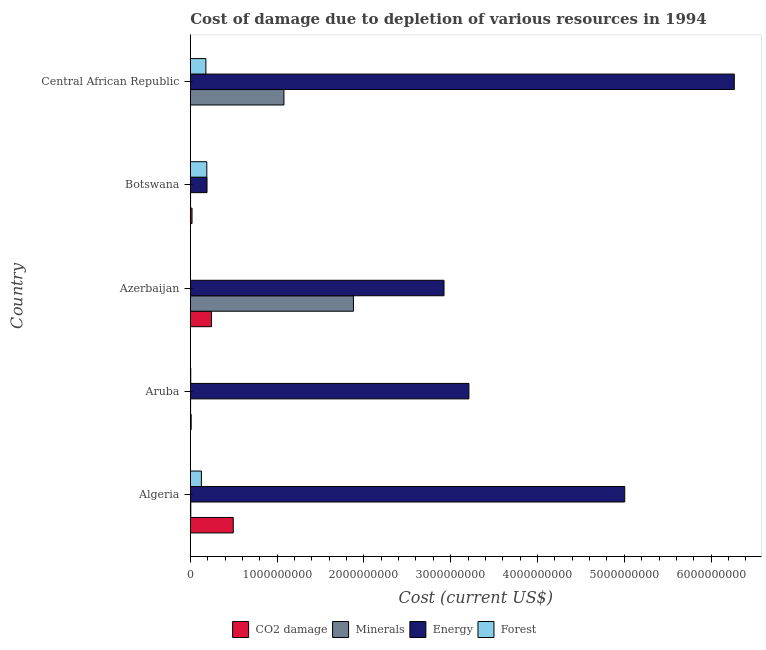How many groups of bars are there?
Offer a very short reply. 5. Are the number of bars on each tick of the Y-axis equal?
Give a very brief answer. Yes. What is the label of the 5th group of bars from the top?
Provide a succinct answer. Algeria. In how many cases, is the number of bars for a given country not equal to the number of legend labels?
Ensure brevity in your answer.  0. What is the cost of damage due to depletion of forests in Botswana?
Your answer should be compact. 1.90e+08. Across all countries, what is the maximum cost of damage due to depletion of coal?
Offer a very short reply. 4.95e+08. Across all countries, what is the minimum cost of damage due to depletion of forests?
Offer a very short reply. 4.39e+05. In which country was the cost of damage due to depletion of forests maximum?
Ensure brevity in your answer.  Botswana. In which country was the cost of damage due to depletion of forests minimum?
Make the answer very short. Azerbaijan. What is the total cost of damage due to depletion of coal in the graph?
Keep it short and to the point. 7.70e+08. What is the difference between the cost of damage due to depletion of forests in Algeria and that in Botswana?
Ensure brevity in your answer.  -6.25e+07. What is the difference between the cost of damage due to depletion of minerals in Botswana and the cost of damage due to depletion of forests in Central African Republic?
Keep it short and to the point. -1.77e+08. What is the average cost of damage due to depletion of energy per country?
Give a very brief answer. 3.52e+09. What is the difference between the cost of damage due to depletion of minerals and cost of damage due to depletion of energy in Algeria?
Offer a terse response. -5.00e+09. In how many countries, is the cost of damage due to depletion of energy greater than 5600000000 US$?
Provide a short and direct response. 1. What is the ratio of the cost of damage due to depletion of forests in Azerbaijan to that in Botswana?
Provide a succinct answer. 0. What is the difference between the highest and the second highest cost of damage due to depletion of coal?
Make the answer very short. 2.51e+08. What is the difference between the highest and the lowest cost of damage due to depletion of energy?
Give a very brief answer. 6.07e+09. Is the sum of the cost of damage due to depletion of coal in Azerbaijan and Central African Republic greater than the maximum cost of damage due to depletion of minerals across all countries?
Your answer should be very brief. No. Is it the case that in every country, the sum of the cost of damage due to depletion of energy and cost of damage due to depletion of coal is greater than the sum of cost of damage due to depletion of forests and cost of damage due to depletion of minerals?
Ensure brevity in your answer.  Yes. What does the 4th bar from the top in Aruba represents?
Provide a short and direct response. CO2 damage. What does the 1st bar from the bottom in Aruba represents?
Your answer should be very brief. CO2 damage. How many countries are there in the graph?
Give a very brief answer. 5. Are the values on the major ticks of X-axis written in scientific E-notation?
Offer a terse response. No. Does the graph contain any zero values?
Offer a very short reply. No. Does the graph contain grids?
Your answer should be compact. No. Where does the legend appear in the graph?
Your answer should be compact. Bottom center. How many legend labels are there?
Your answer should be very brief. 4. How are the legend labels stacked?
Make the answer very short. Horizontal. What is the title of the graph?
Keep it short and to the point. Cost of damage due to depletion of various resources in 1994 . Does "Source data assessment" appear as one of the legend labels in the graph?
Make the answer very short. No. What is the label or title of the X-axis?
Your answer should be compact. Cost (current US$). What is the label or title of the Y-axis?
Ensure brevity in your answer.  Country. What is the Cost (current US$) of CO2 damage in Algeria?
Provide a succinct answer. 4.95e+08. What is the Cost (current US$) of Minerals in Algeria?
Your response must be concise. 5.54e+06. What is the Cost (current US$) in Energy in Algeria?
Ensure brevity in your answer.  5.01e+09. What is the Cost (current US$) of Forest in Algeria?
Your answer should be very brief. 1.28e+08. What is the Cost (current US$) in CO2 damage in Aruba?
Provide a short and direct response. 1.01e+07. What is the Cost (current US$) in Minerals in Aruba?
Ensure brevity in your answer.  3.46e+06. What is the Cost (current US$) of Energy in Aruba?
Offer a very short reply. 3.21e+09. What is the Cost (current US$) in Forest in Aruba?
Keep it short and to the point. 5.19e+06. What is the Cost (current US$) in CO2 damage in Azerbaijan?
Give a very brief answer. 2.44e+08. What is the Cost (current US$) in Minerals in Azerbaijan?
Give a very brief answer. 1.88e+09. What is the Cost (current US$) of Energy in Azerbaijan?
Ensure brevity in your answer.  2.92e+09. What is the Cost (current US$) of Forest in Azerbaijan?
Offer a terse response. 4.39e+05. What is the Cost (current US$) of CO2 damage in Botswana?
Provide a short and direct response. 2.00e+07. What is the Cost (current US$) in Minerals in Botswana?
Give a very brief answer. 3.12e+06. What is the Cost (current US$) of Energy in Botswana?
Provide a succinct answer. 1.93e+08. What is the Cost (current US$) of Forest in Botswana?
Your response must be concise. 1.90e+08. What is the Cost (current US$) of CO2 damage in Central African Republic?
Make the answer very short. 1.34e+06. What is the Cost (current US$) of Minerals in Central African Republic?
Your answer should be compact. 1.08e+09. What is the Cost (current US$) in Energy in Central African Republic?
Provide a succinct answer. 6.27e+09. What is the Cost (current US$) in Forest in Central African Republic?
Provide a short and direct response. 1.80e+08. Across all countries, what is the maximum Cost (current US$) of CO2 damage?
Keep it short and to the point. 4.95e+08. Across all countries, what is the maximum Cost (current US$) in Minerals?
Your response must be concise. 1.88e+09. Across all countries, what is the maximum Cost (current US$) of Energy?
Your answer should be compact. 6.27e+09. Across all countries, what is the maximum Cost (current US$) of Forest?
Your answer should be compact. 1.90e+08. Across all countries, what is the minimum Cost (current US$) of CO2 damage?
Provide a short and direct response. 1.34e+06. Across all countries, what is the minimum Cost (current US$) of Minerals?
Your answer should be compact. 3.12e+06. Across all countries, what is the minimum Cost (current US$) of Energy?
Provide a succinct answer. 1.93e+08. Across all countries, what is the minimum Cost (current US$) of Forest?
Keep it short and to the point. 4.39e+05. What is the total Cost (current US$) in CO2 damage in the graph?
Your response must be concise. 7.70e+08. What is the total Cost (current US$) in Minerals in the graph?
Provide a succinct answer. 2.97e+09. What is the total Cost (current US$) in Energy in the graph?
Your response must be concise. 1.76e+1. What is the total Cost (current US$) in Forest in the graph?
Keep it short and to the point. 5.03e+08. What is the difference between the Cost (current US$) in CO2 damage in Algeria and that in Aruba?
Your answer should be compact. 4.85e+08. What is the difference between the Cost (current US$) of Minerals in Algeria and that in Aruba?
Your answer should be very brief. 2.08e+06. What is the difference between the Cost (current US$) in Energy in Algeria and that in Aruba?
Offer a very short reply. 1.80e+09. What is the difference between the Cost (current US$) of Forest in Algeria and that in Aruba?
Make the answer very short. 1.23e+08. What is the difference between the Cost (current US$) of CO2 damage in Algeria and that in Azerbaijan?
Provide a succinct answer. 2.51e+08. What is the difference between the Cost (current US$) of Minerals in Algeria and that in Azerbaijan?
Your answer should be compact. -1.87e+09. What is the difference between the Cost (current US$) in Energy in Algeria and that in Azerbaijan?
Offer a terse response. 2.08e+09. What is the difference between the Cost (current US$) in Forest in Algeria and that in Azerbaijan?
Keep it short and to the point. 1.27e+08. What is the difference between the Cost (current US$) in CO2 damage in Algeria and that in Botswana?
Keep it short and to the point. 4.75e+08. What is the difference between the Cost (current US$) of Minerals in Algeria and that in Botswana?
Ensure brevity in your answer.  2.42e+06. What is the difference between the Cost (current US$) of Energy in Algeria and that in Botswana?
Your answer should be very brief. 4.81e+09. What is the difference between the Cost (current US$) in Forest in Algeria and that in Botswana?
Keep it short and to the point. -6.25e+07. What is the difference between the Cost (current US$) of CO2 damage in Algeria and that in Central African Republic?
Your response must be concise. 4.94e+08. What is the difference between the Cost (current US$) of Minerals in Algeria and that in Central African Republic?
Your response must be concise. -1.07e+09. What is the difference between the Cost (current US$) of Energy in Algeria and that in Central African Republic?
Offer a very short reply. -1.26e+09. What is the difference between the Cost (current US$) in Forest in Algeria and that in Central African Republic?
Offer a very short reply. -5.19e+07. What is the difference between the Cost (current US$) of CO2 damage in Aruba and that in Azerbaijan?
Your answer should be compact. -2.34e+08. What is the difference between the Cost (current US$) of Minerals in Aruba and that in Azerbaijan?
Give a very brief answer. -1.88e+09. What is the difference between the Cost (current US$) in Energy in Aruba and that in Azerbaijan?
Offer a very short reply. 2.87e+08. What is the difference between the Cost (current US$) in Forest in Aruba and that in Azerbaijan?
Your answer should be very brief. 4.75e+06. What is the difference between the Cost (current US$) in CO2 damage in Aruba and that in Botswana?
Offer a terse response. -9.90e+06. What is the difference between the Cost (current US$) in Minerals in Aruba and that in Botswana?
Give a very brief answer. 3.38e+05. What is the difference between the Cost (current US$) of Energy in Aruba and that in Botswana?
Your answer should be compact. 3.02e+09. What is the difference between the Cost (current US$) of Forest in Aruba and that in Botswana?
Provide a short and direct response. -1.85e+08. What is the difference between the Cost (current US$) of CO2 damage in Aruba and that in Central African Republic?
Keep it short and to the point. 8.75e+06. What is the difference between the Cost (current US$) in Minerals in Aruba and that in Central African Republic?
Offer a very short reply. -1.08e+09. What is the difference between the Cost (current US$) in Energy in Aruba and that in Central African Republic?
Give a very brief answer. -3.06e+09. What is the difference between the Cost (current US$) in Forest in Aruba and that in Central African Republic?
Offer a terse response. -1.74e+08. What is the difference between the Cost (current US$) in CO2 damage in Azerbaijan and that in Botswana?
Your answer should be very brief. 2.24e+08. What is the difference between the Cost (current US$) of Minerals in Azerbaijan and that in Botswana?
Your answer should be compact. 1.88e+09. What is the difference between the Cost (current US$) of Energy in Azerbaijan and that in Botswana?
Ensure brevity in your answer.  2.73e+09. What is the difference between the Cost (current US$) of Forest in Azerbaijan and that in Botswana?
Your answer should be very brief. -1.90e+08. What is the difference between the Cost (current US$) in CO2 damage in Azerbaijan and that in Central African Republic?
Your response must be concise. 2.43e+08. What is the difference between the Cost (current US$) of Minerals in Azerbaijan and that in Central African Republic?
Ensure brevity in your answer.  8.01e+08. What is the difference between the Cost (current US$) of Energy in Azerbaijan and that in Central African Republic?
Offer a terse response. -3.34e+09. What is the difference between the Cost (current US$) of Forest in Azerbaijan and that in Central African Republic?
Your answer should be compact. -1.79e+08. What is the difference between the Cost (current US$) of CO2 damage in Botswana and that in Central African Republic?
Keep it short and to the point. 1.87e+07. What is the difference between the Cost (current US$) in Minerals in Botswana and that in Central African Republic?
Your answer should be compact. -1.08e+09. What is the difference between the Cost (current US$) in Energy in Botswana and that in Central African Republic?
Your answer should be compact. -6.07e+09. What is the difference between the Cost (current US$) of Forest in Botswana and that in Central African Republic?
Give a very brief answer. 1.06e+07. What is the difference between the Cost (current US$) of CO2 damage in Algeria and the Cost (current US$) of Minerals in Aruba?
Offer a very short reply. 4.91e+08. What is the difference between the Cost (current US$) in CO2 damage in Algeria and the Cost (current US$) in Energy in Aruba?
Provide a succinct answer. -2.71e+09. What is the difference between the Cost (current US$) of CO2 damage in Algeria and the Cost (current US$) of Forest in Aruba?
Provide a succinct answer. 4.90e+08. What is the difference between the Cost (current US$) of Minerals in Algeria and the Cost (current US$) of Energy in Aruba?
Your answer should be very brief. -3.20e+09. What is the difference between the Cost (current US$) of Minerals in Algeria and the Cost (current US$) of Forest in Aruba?
Your answer should be compact. 3.60e+05. What is the difference between the Cost (current US$) of Energy in Algeria and the Cost (current US$) of Forest in Aruba?
Make the answer very short. 5.00e+09. What is the difference between the Cost (current US$) of CO2 damage in Algeria and the Cost (current US$) of Minerals in Azerbaijan?
Make the answer very short. -1.38e+09. What is the difference between the Cost (current US$) in CO2 damage in Algeria and the Cost (current US$) in Energy in Azerbaijan?
Offer a very short reply. -2.43e+09. What is the difference between the Cost (current US$) of CO2 damage in Algeria and the Cost (current US$) of Forest in Azerbaijan?
Provide a succinct answer. 4.94e+08. What is the difference between the Cost (current US$) in Minerals in Algeria and the Cost (current US$) in Energy in Azerbaijan?
Offer a very short reply. -2.92e+09. What is the difference between the Cost (current US$) in Minerals in Algeria and the Cost (current US$) in Forest in Azerbaijan?
Give a very brief answer. 5.11e+06. What is the difference between the Cost (current US$) in Energy in Algeria and the Cost (current US$) in Forest in Azerbaijan?
Provide a succinct answer. 5.00e+09. What is the difference between the Cost (current US$) of CO2 damage in Algeria and the Cost (current US$) of Minerals in Botswana?
Provide a succinct answer. 4.92e+08. What is the difference between the Cost (current US$) in CO2 damage in Algeria and the Cost (current US$) in Energy in Botswana?
Make the answer very short. 3.02e+08. What is the difference between the Cost (current US$) of CO2 damage in Algeria and the Cost (current US$) of Forest in Botswana?
Ensure brevity in your answer.  3.05e+08. What is the difference between the Cost (current US$) of Minerals in Algeria and the Cost (current US$) of Energy in Botswana?
Your response must be concise. -1.87e+08. What is the difference between the Cost (current US$) in Minerals in Algeria and the Cost (current US$) in Forest in Botswana?
Keep it short and to the point. -1.85e+08. What is the difference between the Cost (current US$) of Energy in Algeria and the Cost (current US$) of Forest in Botswana?
Your answer should be compact. 4.81e+09. What is the difference between the Cost (current US$) of CO2 damage in Algeria and the Cost (current US$) of Minerals in Central African Republic?
Provide a short and direct response. -5.84e+08. What is the difference between the Cost (current US$) of CO2 damage in Algeria and the Cost (current US$) of Energy in Central African Republic?
Offer a very short reply. -5.77e+09. What is the difference between the Cost (current US$) of CO2 damage in Algeria and the Cost (current US$) of Forest in Central African Republic?
Your response must be concise. 3.15e+08. What is the difference between the Cost (current US$) in Minerals in Algeria and the Cost (current US$) in Energy in Central African Republic?
Ensure brevity in your answer.  -6.26e+09. What is the difference between the Cost (current US$) of Minerals in Algeria and the Cost (current US$) of Forest in Central African Republic?
Your answer should be compact. -1.74e+08. What is the difference between the Cost (current US$) in Energy in Algeria and the Cost (current US$) in Forest in Central African Republic?
Provide a succinct answer. 4.83e+09. What is the difference between the Cost (current US$) of CO2 damage in Aruba and the Cost (current US$) of Minerals in Azerbaijan?
Make the answer very short. -1.87e+09. What is the difference between the Cost (current US$) of CO2 damage in Aruba and the Cost (current US$) of Energy in Azerbaijan?
Your answer should be very brief. -2.91e+09. What is the difference between the Cost (current US$) of CO2 damage in Aruba and the Cost (current US$) of Forest in Azerbaijan?
Your response must be concise. 9.65e+06. What is the difference between the Cost (current US$) of Minerals in Aruba and the Cost (current US$) of Energy in Azerbaijan?
Your answer should be compact. -2.92e+09. What is the difference between the Cost (current US$) of Minerals in Aruba and the Cost (current US$) of Forest in Azerbaijan?
Give a very brief answer. 3.02e+06. What is the difference between the Cost (current US$) in Energy in Aruba and the Cost (current US$) in Forest in Azerbaijan?
Your response must be concise. 3.21e+09. What is the difference between the Cost (current US$) of CO2 damage in Aruba and the Cost (current US$) of Minerals in Botswana?
Keep it short and to the point. 6.97e+06. What is the difference between the Cost (current US$) in CO2 damage in Aruba and the Cost (current US$) in Energy in Botswana?
Give a very brief answer. -1.83e+08. What is the difference between the Cost (current US$) in CO2 damage in Aruba and the Cost (current US$) in Forest in Botswana?
Give a very brief answer. -1.80e+08. What is the difference between the Cost (current US$) of Minerals in Aruba and the Cost (current US$) of Energy in Botswana?
Your answer should be compact. -1.89e+08. What is the difference between the Cost (current US$) of Minerals in Aruba and the Cost (current US$) of Forest in Botswana?
Offer a terse response. -1.87e+08. What is the difference between the Cost (current US$) in Energy in Aruba and the Cost (current US$) in Forest in Botswana?
Your answer should be very brief. 3.02e+09. What is the difference between the Cost (current US$) in CO2 damage in Aruba and the Cost (current US$) in Minerals in Central African Republic?
Keep it short and to the point. -1.07e+09. What is the difference between the Cost (current US$) of CO2 damage in Aruba and the Cost (current US$) of Energy in Central African Republic?
Offer a very short reply. -6.26e+09. What is the difference between the Cost (current US$) in CO2 damage in Aruba and the Cost (current US$) in Forest in Central African Republic?
Your response must be concise. -1.70e+08. What is the difference between the Cost (current US$) of Minerals in Aruba and the Cost (current US$) of Energy in Central African Republic?
Offer a terse response. -6.26e+09. What is the difference between the Cost (current US$) in Minerals in Aruba and the Cost (current US$) in Forest in Central African Republic?
Provide a short and direct response. -1.76e+08. What is the difference between the Cost (current US$) in Energy in Aruba and the Cost (current US$) in Forest in Central African Republic?
Your answer should be very brief. 3.03e+09. What is the difference between the Cost (current US$) in CO2 damage in Azerbaijan and the Cost (current US$) in Minerals in Botswana?
Your answer should be compact. 2.41e+08. What is the difference between the Cost (current US$) in CO2 damage in Azerbaijan and the Cost (current US$) in Energy in Botswana?
Your response must be concise. 5.15e+07. What is the difference between the Cost (current US$) in CO2 damage in Azerbaijan and the Cost (current US$) in Forest in Botswana?
Offer a very short reply. 5.38e+07. What is the difference between the Cost (current US$) of Minerals in Azerbaijan and the Cost (current US$) of Energy in Botswana?
Provide a succinct answer. 1.69e+09. What is the difference between the Cost (current US$) of Minerals in Azerbaijan and the Cost (current US$) of Forest in Botswana?
Provide a succinct answer. 1.69e+09. What is the difference between the Cost (current US$) in Energy in Azerbaijan and the Cost (current US$) in Forest in Botswana?
Ensure brevity in your answer.  2.73e+09. What is the difference between the Cost (current US$) of CO2 damage in Azerbaijan and the Cost (current US$) of Minerals in Central African Republic?
Keep it short and to the point. -8.35e+08. What is the difference between the Cost (current US$) of CO2 damage in Azerbaijan and the Cost (current US$) of Energy in Central African Republic?
Your response must be concise. -6.02e+09. What is the difference between the Cost (current US$) in CO2 damage in Azerbaijan and the Cost (current US$) in Forest in Central African Republic?
Make the answer very short. 6.45e+07. What is the difference between the Cost (current US$) of Minerals in Azerbaijan and the Cost (current US$) of Energy in Central African Republic?
Your answer should be very brief. -4.39e+09. What is the difference between the Cost (current US$) of Minerals in Azerbaijan and the Cost (current US$) of Forest in Central African Republic?
Your answer should be compact. 1.70e+09. What is the difference between the Cost (current US$) of Energy in Azerbaijan and the Cost (current US$) of Forest in Central African Republic?
Provide a short and direct response. 2.74e+09. What is the difference between the Cost (current US$) of CO2 damage in Botswana and the Cost (current US$) of Minerals in Central African Republic?
Provide a short and direct response. -1.06e+09. What is the difference between the Cost (current US$) of CO2 damage in Botswana and the Cost (current US$) of Energy in Central African Republic?
Offer a terse response. -6.25e+09. What is the difference between the Cost (current US$) of CO2 damage in Botswana and the Cost (current US$) of Forest in Central African Republic?
Offer a very short reply. -1.60e+08. What is the difference between the Cost (current US$) of Minerals in Botswana and the Cost (current US$) of Energy in Central African Republic?
Your answer should be compact. -6.26e+09. What is the difference between the Cost (current US$) in Minerals in Botswana and the Cost (current US$) in Forest in Central African Republic?
Your answer should be very brief. -1.77e+08. What is the difference between the Cost (current US$) of Energy in Botswana and the Cost (current US$) of Forest in Central African Republic?
Offer a terse response. 1.30e+07. What is the average Cost (current US$) in CO2 damage per country?
Your response must be concise. 1.54e+08. What is the average Cost (current US$) of Minerals per country?
Keep it short and to the point. 5.94e+08. What is the average Cost (current US$) in Energy per country?
Keep it short and to the point. 3.52e+09. What is the average Cost (current US$) in Forest per country?
Ensure brevity in your answer.  1.01e+08. What is the difference between the Cost (current US$) in CO2 damage and Cost (current US$) in Minerals in Algeria?
Make the answer very short. 4.89e+08. What is the difference between the Cost (current US$) of CO2 damage and Cost (current US$) of Energy in Algeria?
Ensure brevity in your answer.  -4.51e+09. What is the difference between the Cost (current US$) of CO2 damage and Cost (current US$) of Forest in Algeria?
Your answer should be compact. 3.67e+08. What is the difference between the Cost (current US$) of Minerals and Cost (current US$) of Energy in Algeria?
Ensure brevity in your answer.  -5.00e+09. What is the difference between the Cost (current US$) in Minerals and Cost (current US$) in Forest in Algeria?
Ensure brevity in your answer.  -1.22e+08. What is the difference between the Cost (current US$) in Energy and Cost (current US$) in Forest in Algeria?
Your answer should be very brief. 4.88e+09. What is the difference between the Cost (current US$) of CO2 damage and Cost (current US$) of Minerals in Aruba?
Keep it short and to the point. 6.63e+06. What is the difference between the Cost (current US$) of CO2 damage and Cost (current US$) of Energy in Aruba?
Offer a very short reply. -3.20e+09. What is the difference between the Cost (current US$) in CO2 damage and Cost (current US$) in Forest in Aruba?
Keep it short and to the point. 4.91e+06. What is the difference between the Cost (current US$) in Minerals and Cost (current US$) in Energy in Aruba?
Provide a short and direct response. -3.21e+09. What is the difference between the Cost (current US$) in Minerals and Cost (current US$) in Forest in Aruba?
Provide a succinct answer. -1.72e+06. What is the difference between the Cost (current US$) in Energy and Cost (current US$) in Forest in Aruba?
Provide a succinct answer. 3.20e+09. What is the difference between the Cost (current US$) of CO2 damage and Cost (current US$) of Minerals in Azerbaijan?
Provide a succinct answer. -1.64e+09. What is the difference between the Cost (current US$) in CO2 damage and Cost (current US$) in Energy in Azerbaijan?
Ensure brevity in your answer.  -2.68e+09. What is the difference between the Cost (current US$) in CO2 damage and Cost (current US$) in Forest in Azerbaijan?
Your response must be concise. 2.44e+08. What is the difference between the Cost (current US$) of Minerals and Cost (current US$) of Energy in Azerbaijan?
Make the answer very short. -1.04e+09. What is the difference between the Cost (current US$) of Minerals and Cost (current US$) of Forest in Azerbaijan?
Offer a very short reply. 1.88e+09. What is the difference between the Cost (current US$) of Energy and Cost (current US$) of Forest in Azerbaijan?
Offer a terse response. 2.92e+09. What is the difference between the Cost (current US$) of CO2 damage and Cost (current US$) of Minerals in Botswana?
Provide a short and direct response. 1.69e+07. What is the difference between the Cost (current US$) of CO2 damage and Cost (current US$) of Energy in Botswana?
Provide a succinct answer. -1.73e+08. What is the difference between the Cost (current US$) of CO2 damage and Cost (current US$) of Forest in Botswana?
Keep it short and to the point. -1.70e+08. What is the difference between the Cost (current US$) in Minerals and Cost (current US$) in Energy in Botswana?
Give a very brief answer. -1.89e+08. What is the difference between the Cost (current US$) in Minerals and Cost (current US$) in Forest in Botswana?
Your answer should be compact. -1.87e+08. What is the difference between the Cost (current US$) of Energy and Cost (current US$) of Forest in Botswana?
Provide a short and direct response. 2.31e+06. What is the difference between the Cost (current US$) of CO2 damage and Cost (current US$) of Minerals in Central African Republic?
Offer a terse response. -1.08e+09. What is the difference between the Cost (current US$) of CO2 damage and Cost (current US$) of Energy in Central African Republic?
Your answer should be compact. -6.27e+09. What is the difference between the Cost (current US$) of CO2 damage and Cost (current US$) of Forest in Central African Republic?
Provide a succinct answer. -1.78e+08. What is the difference between the Cost (current US$) of Minerals and Cost (current US$) of Energy in Central African Republic?
Ensure brevity in your answer.  -5.19e+09. What is the difference between the Cost (current US$) of Minerals and Cost (current US$) of Forest in Central African Republic?
Give a very brief answer. 8.99e+08. What is the difference between the Cost (current US$) in Energy and Cost (current US$) in Forest in Central African Republic?
Keep it short and to the point. 6.09e+09. What is the ratio of the Cost (current US$) in CO2 damage in Algeria to that in Aruba?
Provide a succinct answer. 49.04. What is the ratio of the Cost (current US$) of Minerals in Algeria to that in Aruba?
Provide a short and direct response. 1.6. What is the ratio of the Cost (current US$) in Energy in Algeria to that in Aruba?
Make the answer very short. 1.56. What is the ratio of the Cost (current US$) in Forest in Algeria to that in Aruba?
Make the answer very short. 24.64. What is the ratio of the Cost (current US$) of CO2 damage in Algeria to that in Azerbaijan?
Offer a terse response. 2.03. What is the ratio of the Cost (current US$) in Minerals in Algeria to that in Azerbaijan?
Offer a very short reply. 0. What is the ratio of the Cost (current US$) of Energy in Algeria to that in Azerbaijan?
Offer a very short reply. 1.71. What is the ratio of the Cost (current US$) in Forest in Algeria to that in Azerbaijan?
Offer a very short reply. 291.24. What is the ratio of the Cost (current US$) of CO2 damage in Algeria to that in Botswana?
Your response must be concise. 24.75. What is the ratio of the Cost (current US$) of Minerals in Algeria to that in Botswana?
Your answer should be very brief. 1.78. What is the ratio of the Cost (current US$) of Energy in Algeria to that in Botswana?
Give a very brief answer. 25.98. What is the ratio of the Cost (current US$) in Forest in Algeria to that in Botswana?
Your answer should be very brief. 0.67. What is the ratio of the Cost (current US$) in CO2 damage in Algeria to that in Central African Republic?
Provide a short and direct response. 368.58. What is the ratio of the Cost (current US$) of Minerals in Algeria to that in Central African Republic?
Give a very brief answer. 0.01. What is the ratio of the Cost (current US$) of Energy in Algeria to that in Central African Republic?
Offer a very short reply. 0.8. What is the ratio of the Cost (current US$) in Forest in Algeria to that in Central African Republic?
Provide a succinct answer. 0.71. What is the ratio of the Cost (current US$) of CO2 damage in Aruba to that in Azerbaijan?
Your answer should be very brief. 0.04. What is the ratio of the Cost (current US$) in Minerals in Aruba to that in Azerbaijan?
Offer a very short reply. 0. What is the ratio of the Cost (current US$) of Energy in Aruba to that in Azerbaijan?
Ensure brevity in your answer.  1.1. What is the ratio of the Cost (current US$) in Forest in Aruba to that in Azerbaijan?
Make the answer very short. 11.82. What is the ratio of the Cost (current US$) of CO2 damage in Aruba to that in Botswana?
Give a very brief answer. 0.5. What is the ratio of the Cost (current US$) of Minerals in Aruba to that in Botswana?
Offer a terse response. 1.11. What is the ratio of the Cost (current US$) of Energy in Aruba to that in Botswana?
Offer a very short reply. 16.66. What is the ratio of the Cost (current US$) of Forest in Aruba to that in Botswana?
Make the answer very short. 0.03. What is the ratio of the Cost (current US$) of CO2 damage in Aruba to that in Central African Republic?
Provide a succinct answer. 7.52. What is the ratio of the Cost (current US$) in Minerals in Aruba to that in Central African Republic?
Your response must be concise. 0. What is the ratio of the Cost (current US$) in Energy in Aruba to that in Central African Republic?
Give a very brief answer. 0.51. What is the ratio of the Cost (current US$) in Forest in Aruba to that in Central African Republic?
Ensure brevity in your answer.  0.03. What is the ratio of the Cost (current US$) of CO2 damage in Azerbaijan to that in Botswana?
Offer a terse response. 12.21. What is the ratio of the Cost (current US$) of Minerals in Azerbaijan to that in Botswana?
Make the answer very short. 601.81. What is the ratio of the Cost (current US$) of Energy in Azerbaijan to that in Botswana?
Ensure brevity in your answer.  15.17. What is the ratio of the Cost (current US$) of Forest in Azerbaijan to that in Botswana?
Ensure brevity in your answer.  0. What is the ratio of the Cost (current US$) of CO2 damage in Azerbaijan to that in Central African Republic?
Your answer should be compact. 181.83. What is the ratio of the Cost (current US$) of Minerals in Azerbaijan to that in Central African Republic?
Offer a terse response. 1.74. What is the ratio of the Cost (current US$) in Energy in Azerbaijan to that in Central African Republic?
Provide a short and direct response. 0.47. What is the ratio of the Cost (current US$) in Forest in Azerbaijan to that in Central African Republic?
Make the answer very short. 0. What is the ratio of the Cost (current US$) of CO2 damage in Botswana to that in Central African Republic?
Provide a short and direct response. 14.89. What is the ratio of the Cost (current US$) in Minerals in Botswana to that in Central African Republic?
Your answer should be compact. 0. What is the ratio of the Cost (current US$) of Energy in Botswana to that in Central African Republic?
Ensure brevity in your answer.  0.03. What is the ratio of the Cost (current US$) in Forest in Botswana to that in Central African Republic?
Provide a succinct answer. 1.06. What is the difference between the highest and the second highest Cost (current US$) in CO2 damage?
Your answer should be compact. 2.51e+08. What is the difference between the highest and the second highest Cost (current US$) in Minerals?
Provide a short and direct response. 8.01e+08. What is the difference between the highest and the second highest Cost (current US$) of Energy?
Your response must be concise. 1.26e+09. What is the difference between the highest and the second highest Cost (current US$) in Forest?
Your response must be concise. 1.06e+07. What is the difference between the highest and the lowest Cost (current US$) in CO2 damage?
Your answer should be very brief. 4.94e+08. What is the difference between the highest and the lowest Cost (current US$) of Minerals?
Ensure brevity in your answer.  1.88e+09. What is the difference between the highest and the lowest Cost (current US$) of Energy?
Provide a succinct answer. 6.07e+09. What is the difference between the highest and the lowest Cost (current US$) of Forest?
Your answer should be very brief. 1.90e+08. 